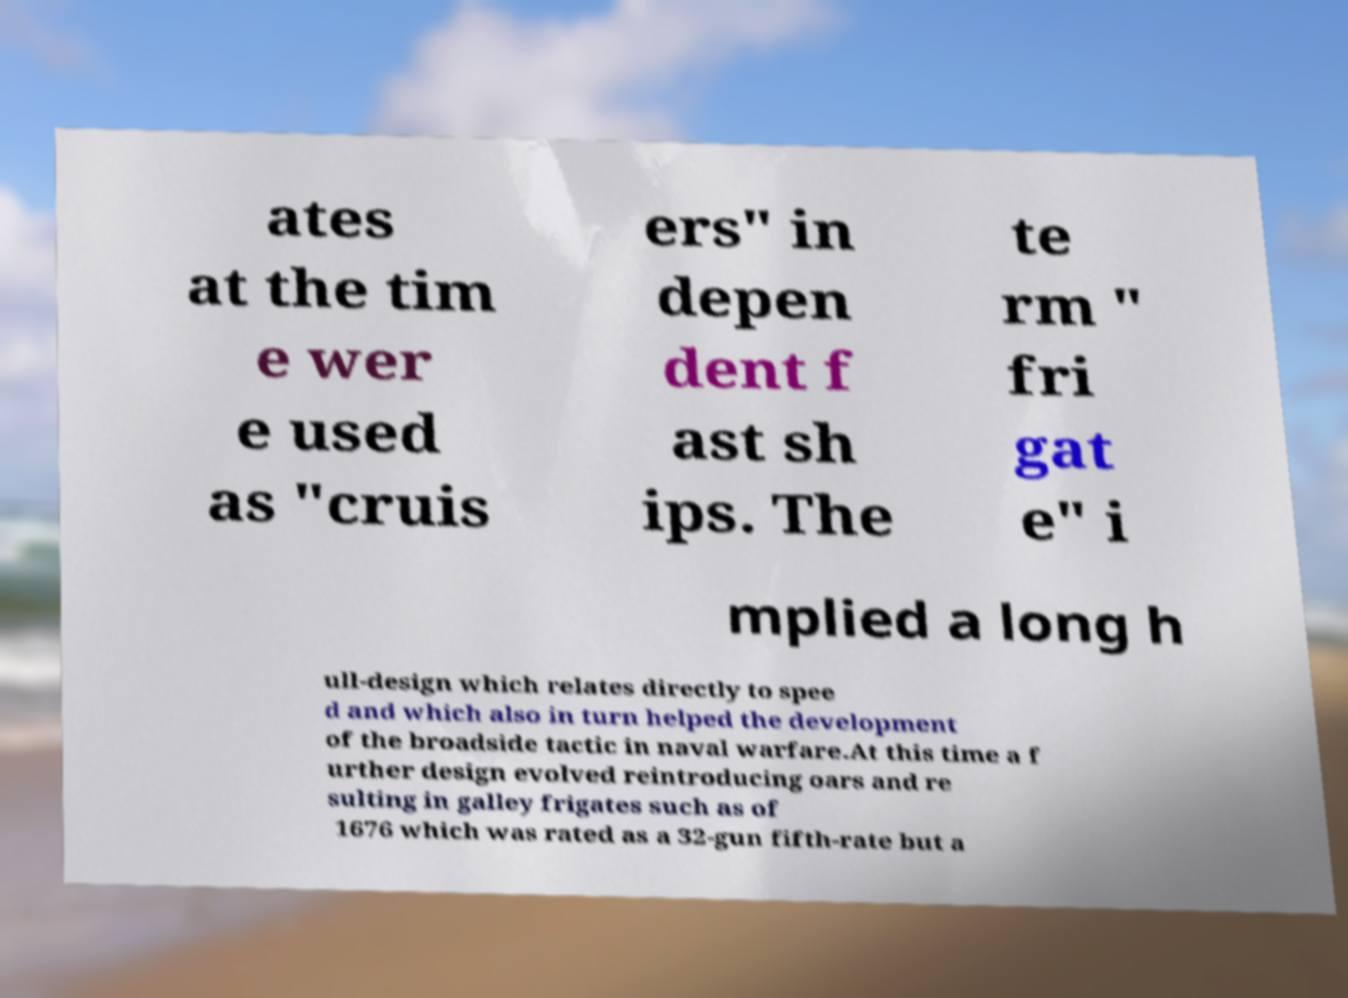There's text embedded in this image that I need extracted. Can you transcribe it verbatim? ates at the tim e wer e used as "cruis ers" in depen dent f ast sh ips. The te rm " fri gat e" i mplied a long h ull-design which relates directly to spee d and which also in turn helped the development of the broadside tactic in naval warfare.At this time a f urther design evolved reintroducing oars and re sulting in galley frigates such as of 1676 which was rated as a 32-gun fifth-rate but a 